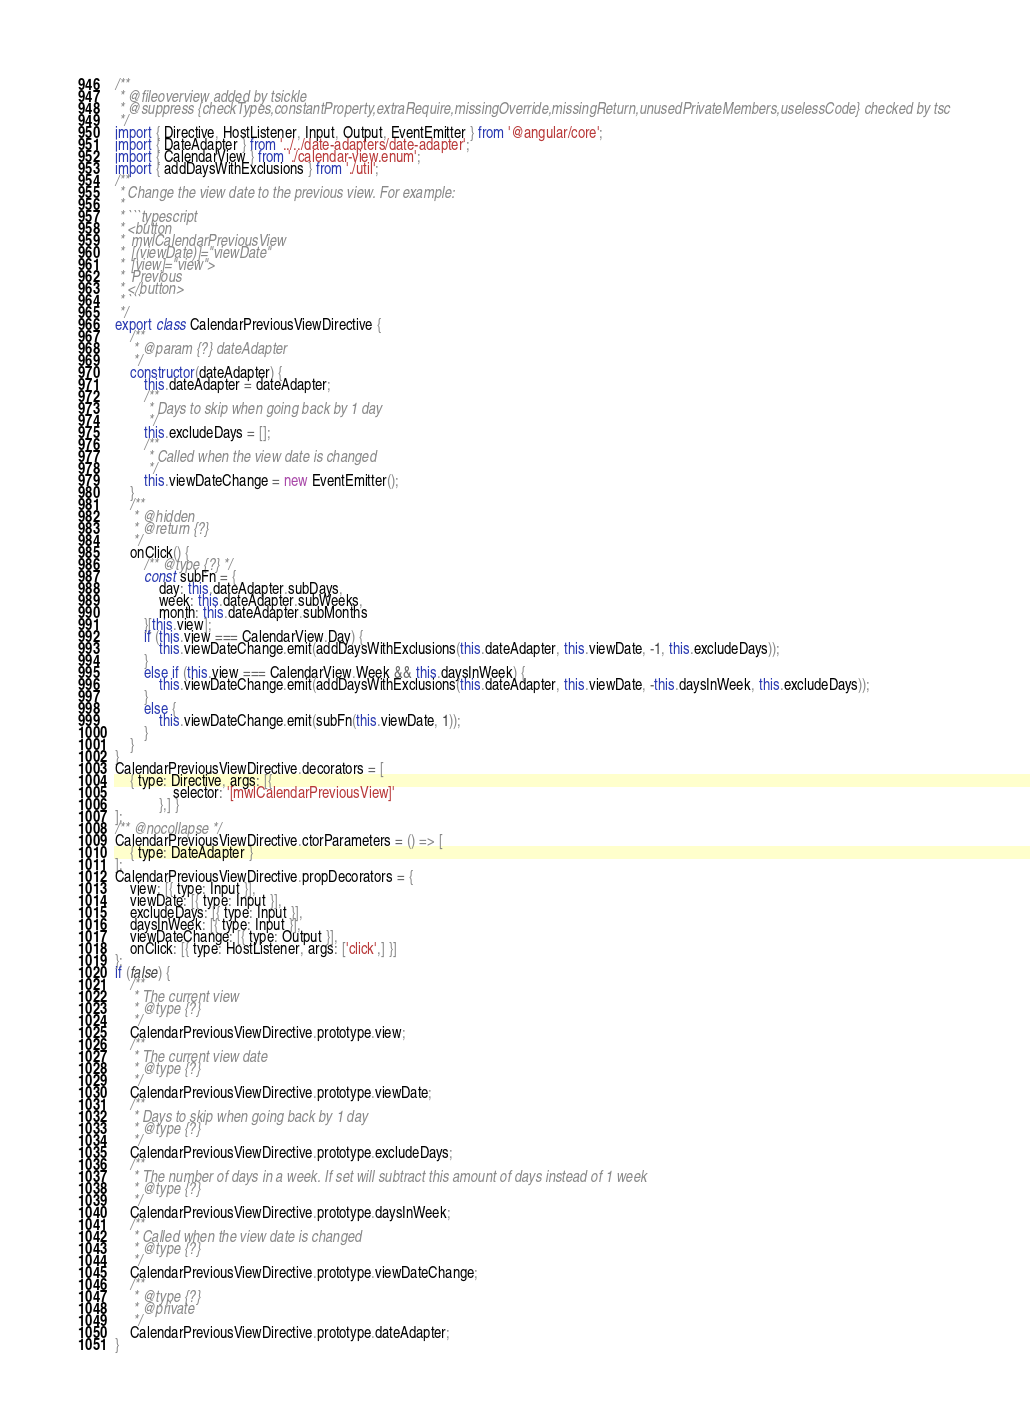<code> <loc_0><loc_0><loc_500><loc_500><_JavaScript_>/**
 * @fileoverview added by tsickle
 * @suppress {checkTypes,constantProperty,extraRequire,missingOverride,missingReturn,unusedPrivateMembers,uselessCode} checked by tsc
 */
import { Directive, HostListener, Input, Output, EventEmitter } from '@angular/core';
import { DateAdapter } from '../../date-adapters/date-adapter';
import { CalendarView } from './calendar-view.enum';
import { addDaysWithExclusions } from './util';
/**
 * Change the view date to the previous view. For example:
 *
 * ```typescript
 * <button
 *  mwlCalendarPreviousView
 *  [(viewDate)]="viewDate"
 *  [view]="view">
 *  Previous
 * </button>
 * ```
 */
export class CalendarPreviousViewDirective {
    /**
     * @param {?} dateAdapter
     */
    constructor(dateAdapter) {
        this.dateAdapter = dateAdapter;
        /**
         * Days to skip when going back by 1 day
         */
        this.excludeDays = [];
        /**
         * Called when the view date is changed
         */
        this.viewDateChange = new EventEmitter();
    }
    /**
     * @hidden
     * @return {?}
     */
    onClick() {
        /** @type {?} */
        const subFn = {
            day: this.dateAdapter.subDays,
            week: this.dateAdapter.subWeeks,
            month: this.dateAdapter.subMonths
        }[this.view];
        if (this.view === CalendarView.Day) {
            this.viewDateChange.emit(addDaysWithExclusions(this.dateAdapter, this.viewDate, -1, this.excludeDays));
        }
        else if (this.view === CalendarView.Week && this.daysInWeek) {
            this.viewDateChange.emit(addDaysWithExclusions(this.dateAdapter, this.viewDate, -this.daysInWeek, this.excludeDays));
        }
        else {
            this.viewDateChange.emit(subFn(this.viewDate, 1));
        }
    }
}
CalendarPreviousViewDirective.decorators = [
    { type: Directive, args: [{
                selector: '[mwlCalendarPreviousView]'
            },] }
];
/** @nocollapse */
CalendarPreviousViewDirective.ctorParameters = () => [
    { type: DateAdapter }
];
CalendarPreviousViewDirective.propDecorators = {
    view: [{ type: Input }],
    viewDate: [{ type: Input }],
    excludeDays: [{ type: Input }],
    daysInWeek: [{ type: Input }],
    viewDateChange: [{ type: Output }],
    onClick: [{ type: HostListener, args: ['click',] }]
};
if (false) {
    /**
     * The current view
     * @type {?}
     */
    CalendarPreviousViewDirective.prototype.view;
    /**
     * The current view date
     * @type {?}
     */
    CalendarPreviousViewDirective.prototype.viewDate;
    /**
     * Days to skip when going back by 1 day
     * @type {?}
     */
    CalendarPreviousViewDirective.prototype.excludeDays;
    /**
     * The number of days in a week. If set will subtract this amount of days instead of 1 week
     * @type {?}
     */
    CalendarPreviousViewDirective.prototype.daysInWeek;
    /**
     * Called when the view date is changed
     * @type {?}
     */
    CalendarPreviousViewDirective.prototype.viewDateChange;
    /**
     * @type {?}
     * @private
     */
    CalendarPreviousViewDirective.prototype.dateAdapter;
}</code> 